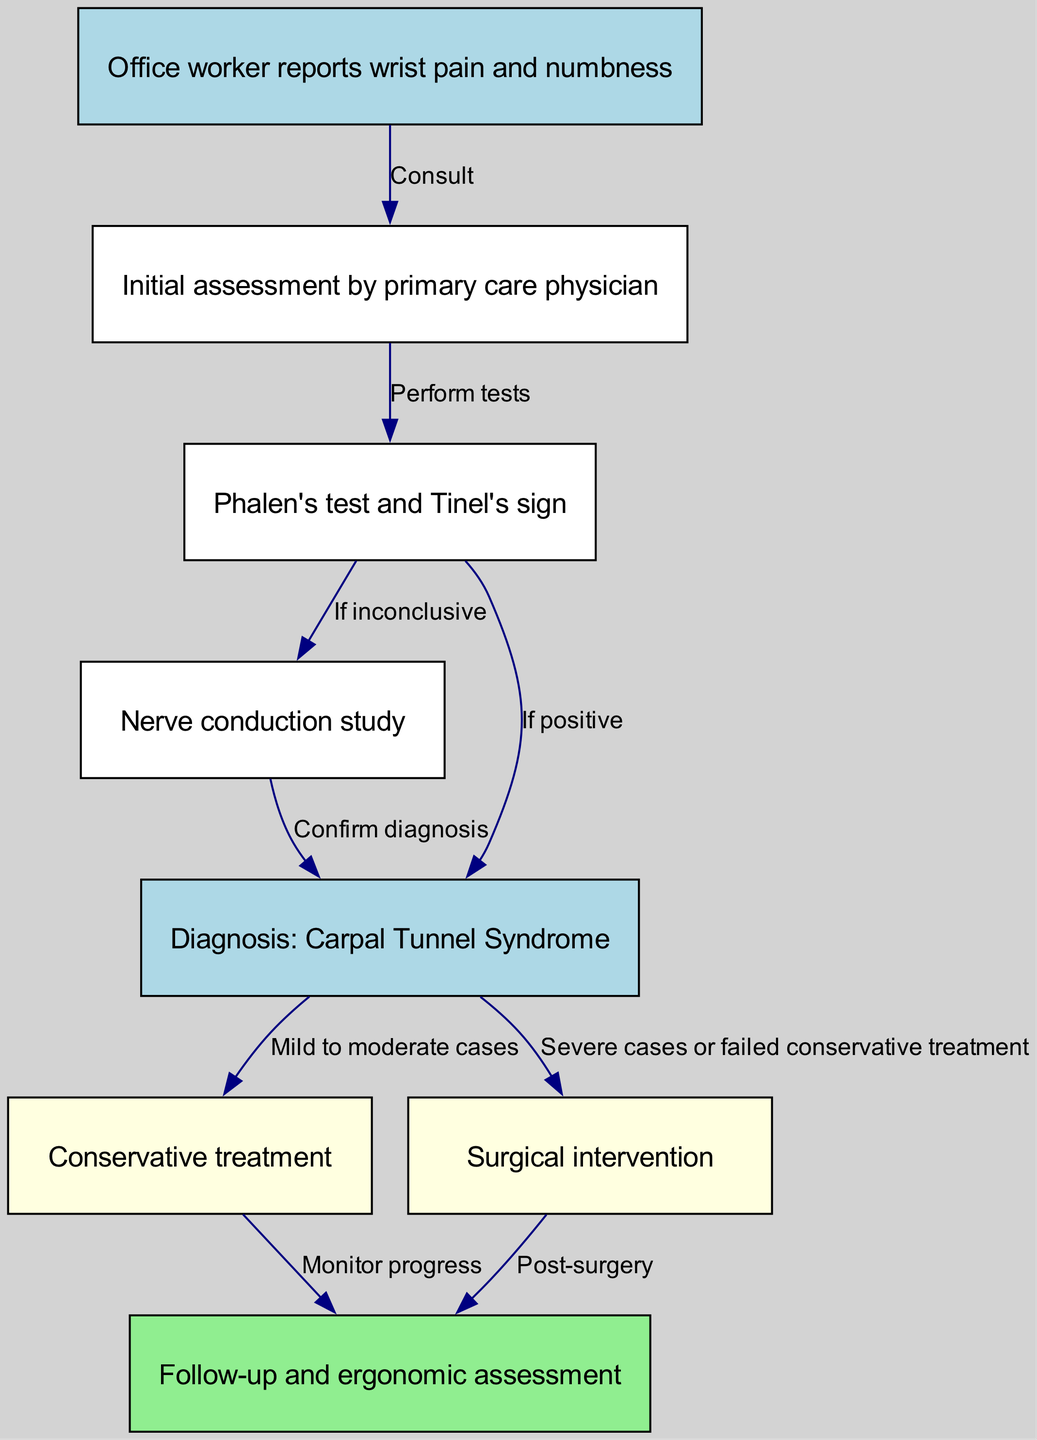What is the first step for an office worker experiencing wrist pain? The diagram shows that an office worker experiencing wrist pain first reports these symptoms to a primary care physician, which is the first step in the treatment pathway.
Answer: Initial assessment by primary care physician How many nodes are present in the diagram? By counting the nodes listed in the diagram, we can determine that there are a total of eight nodes that represent different steps in the treatment pathway for carpal tunnel syndrome.
Answer: 8 What diagnostic test is performed if the physical tests are inconclusive? The diagram indicates that if the initial tests (Phalen's test and Tinel's sign) are inconclusive, a nerve conduction study is the next step in the diagnostic pathway.
Answer: Nerve conduction study What are the two types of treatment after a diagnosis of carpal tunnel syndrome? The diagram illustrates that after the diagnosis, the treatment options are conservative treatment for mild to moderate cases and surgical intervention for severe cases or failed conservative treatment, showing a clear bifurcation in options.
Answer: Conservative treatment and Surgical intervention What happens after surgical intervention? According to the diagram, after surgical intervention, the next step is follow-up and ergonomic assessment, indicating the importance of ongoing evaluation post-procedure.
Answer: Post-surgery What is concluded if Phalen's test and Tinel's sign are positive? If the initial tests conducted yield positive results, the diagram states that the next step in the pathway is to confirm the diagnosis of carpal tunnel syndrome, indicating a direct relationship between the results of the tests and the diagnosis.
Answer: Diagnosis: Carpal Tunnel Syndrome 